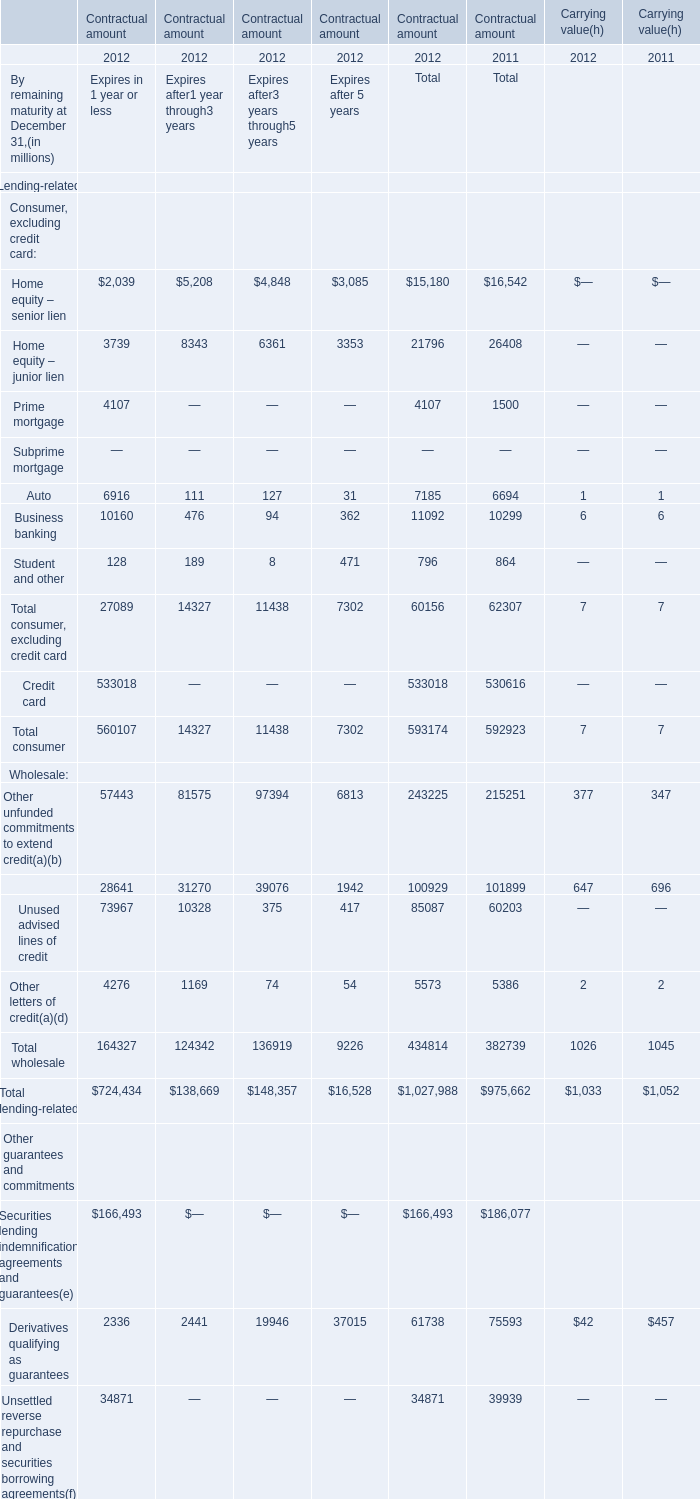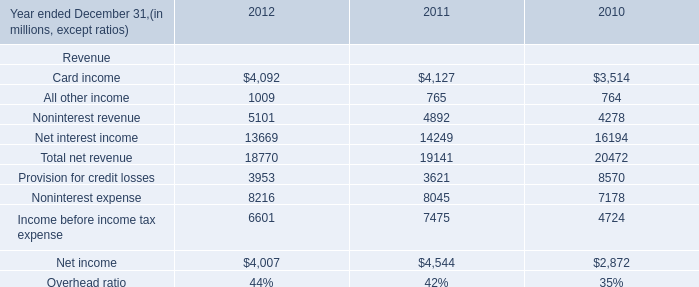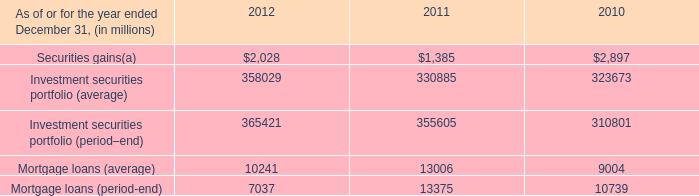What was the total amount of Home equity – senior lien in 2012 ? (in million) 
Computations: (((2039 + 5208) + 4848) + 3085)
Answer: 15180.0. 